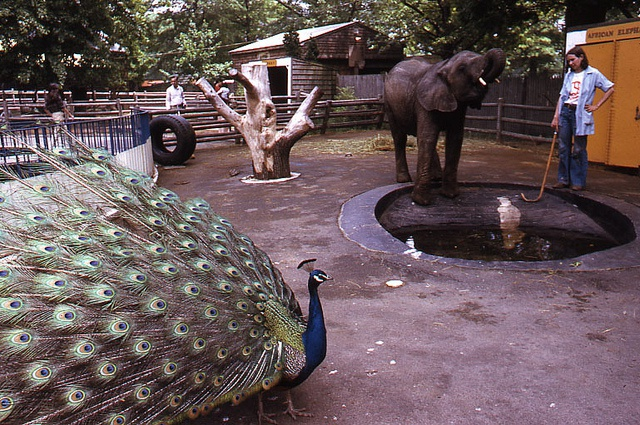Describe the objects in this image and their specific colors. I can see bird in black, gray, maroon, and darkgray tones, elephant in black, gray, and purple tones, people in black, darkgray, brown, and navy tones, people in black, lavender, gray, and maroon tones, and people in black, lavender, maroon, and darkgray tones in this image. 